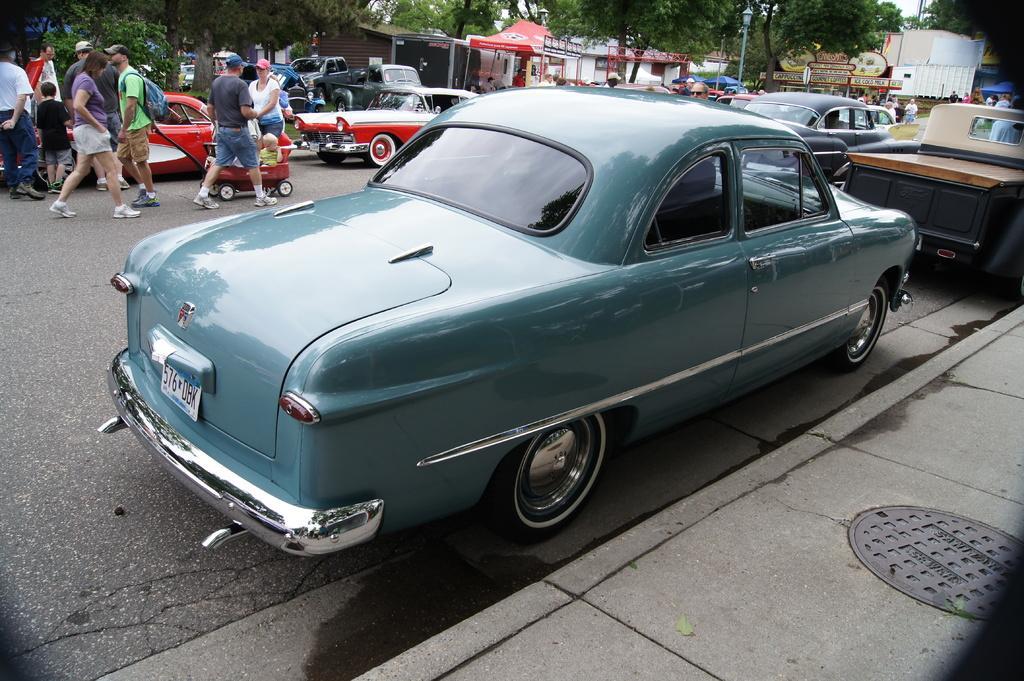Can you describe this image briefly? In this picture there are vehicles on the road and there are group of people walking on the road. At the back there are buildings and trees and poles and there is a tent. At the top there is sky. At the bottom there is a road. In the foreground there is a manhole on the footpath. 